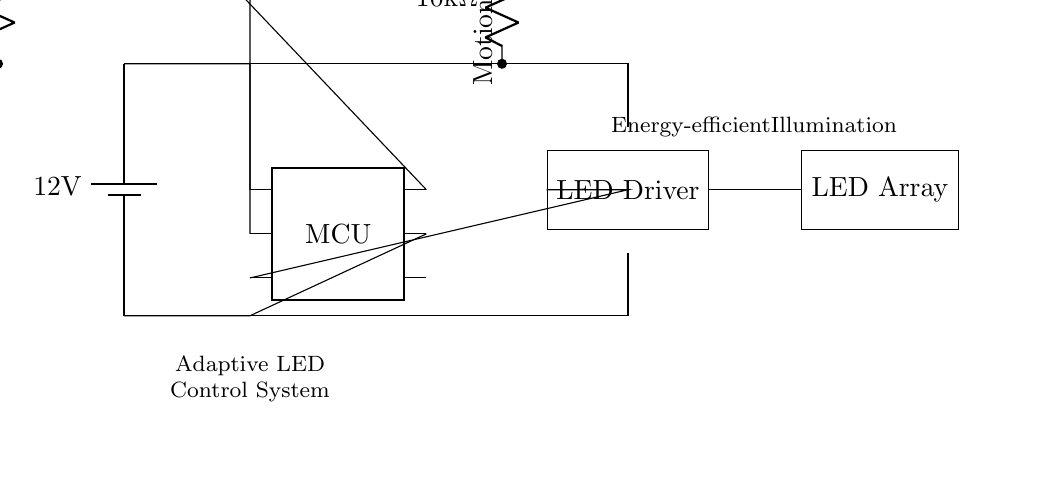What is the voltage of this circuit? The voltage is twelve volts, which is labeled near the battery component in the circuit diagram.
Answer: twelve volts What type of microcontroller is used? The microcontroller is represented by a dipchip icon labeled “MCU.” The diagram does not specify the exact model, but the symbol indicates it’s a microcontroller.
Answer: MCU How many pins does the microcontroller have? The microcontroller in the diagram has six pins, as indicated by the `num pins=6` property in the dipchip notation.
Answer: six What component detects motion in this circuit? The motion sensor is represented by a circular symbol labeled “Motion sensor.” It connects to the microcontroller, indicating its role in detecting motion.
Answer: Motion sensor Why is a light sensor included in the circuit? The light sensor is required to detect ambient light conditions; the microcontroller uses this information to adjust the LED brightness accordingly, enhancing energy efficiency. The presence of a resistor connected to the light sensor indicates it is part of a sensing circuit.
Answer: To detect ambient light What is the purpose of the LED driver in this circuit? The LED driver converts control signals from the microcontroller into appropriate power levels for the LED array, ensuring the LEDs operate efficiently and respond to the system’s control logic based on inputs from the sensors.
Answer: To power the LED array How is the LED array connected to the circuit? The LED array is connected to the LED driver on one end and is powered via connections from the microcontroller, which suggests that the driver regulates how power is supplied to the LEDs based on sensor inputs and control signals.
Answer: Through the LED driver 